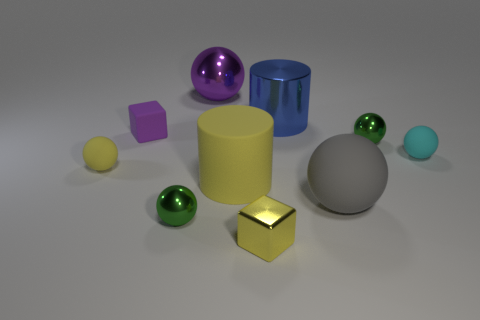How does the lighting in the image affect the perception of the objects? The lighting in the image is soft and diffused, casting subtle shadows and highlights which give depth and dimension to the objects. It creates a calm and balanced atmosphere. The softness of the light ensures there aren't harsh shadows, allowing the true colors and materials of the objects to be more easily discerned. The light direction seems consistent, allowing us to perceive the textures of the objects more clearly. 